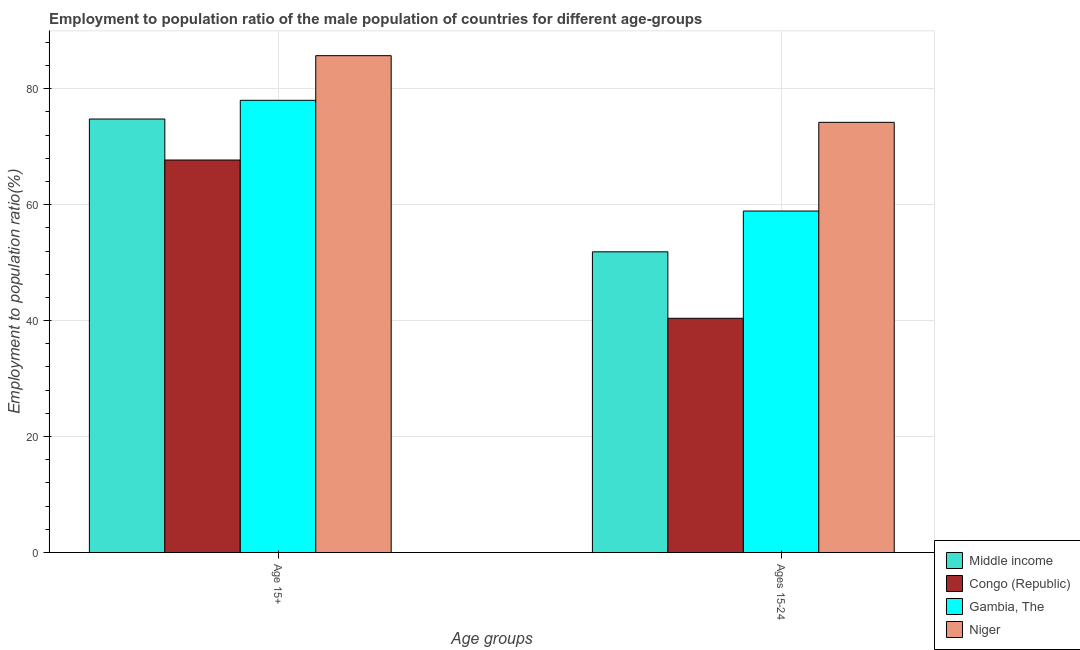How many different coloured bars are there?
Make the answer very short. 4. What is the label of the 2nd group of bars from the left?
Keep it short and to the point. Ages 15-24. What is the employment to population ratio(age 15-24) in Gambia, The?
Keep it short and to the point. 58.9. Across all countries, what is the maximum employment to population ratio(age 15-24)?
Offer a terse response. 74.2. Across all countries, what is the minimum employment to population ratio(age 15-24)?
Your answer should be compact. 40.4. In which country was the employment to population ratio(age 15+) maximum?
Make the answer very short. Niger. In which country was the employment to population ratio(age 15+) minimum?
Ensure brevity in your answer.  Congo (Republic). What is the total employment to population ratio(age 15-24) in the graph?
Provide a succinct answer. 225.37. What is the difference between the employment to population ratio(age 15-24) in Congo (Republic) and that in Niger?
Provide a short and direct response. -33.8. What is the difference between the employment to population ratio(age 15-24) in Congo (Republic) and the employment to population ratio(age 15+) in Niger?
Offer a very short reply. -45.3. What is the average employment to population ratio(age 15-24) per country?
Your answer should be very brief. 56.34. What is the difference between the employment to population ratio(age 15+) and employment to population ratio(age 15-24) in Middle income?
Make the answer very short. 22.91. In how many countries, is the employment to population ratio(age 15-24) greater than 80 %?
Give a very brief answer. 0. What is the ratio of the employment to population ratio(age 15-24) in Middle income to that in Congo (Republic)?
Provide a succinct answer. 1.28. Is the employment to population ratio(age 15+) in Congo (Republic) less than that in Gambia, The?
Your answer should be very brief. Yes. What does the 3rd bar from the left in Age 15+ represents?
Make the answer very short. Gambia, The. What does the 1st bar from the right in Age 15+ represents?
Offer a very short reply. Niger. How many countries are there in the graph?
Keep it short and to the point. 4. What is the difference between two consecutive major ticks on the Y-axis?
Give a very brief answer. 20. Are the values on the major ticks of Y-axis written in scientific E-notation?
Keep it short and to the point. No. Does the graph contain any zero values?
Keep it short and to the point. No. Does the graph contain grids?
Your answer should be compact. Yes. How many legend labels are there?
Your answer should be compact. 4. How are the legend labels stacked?
Offer a very short reply. Vertical. What is the title of the graph?
Your answer should be compact. Employment to population ratio of the male population of countries for different age-groups. What is the label or title of the X-axis?
Offer a terse response. Age groups. What is the label or title of the Y-axis?
Ensure brevity in your answer.  Employment to population ratio(%). What is the Employment to population ratio(%) of Middle income in Age 15+?
Your answer should be compact. 74.77. What is the Employment to population ratio(%) in Congo (Republic) in Age 15+?
Your response must be concise. 67.7. What is the Employment to population ratio(%) in Niger in Age 15+?
Your response must be concise. 85.7. What is the Employment to population ratio(%) of Middle income in Ages 15-24?
Your answer should be very brief. 51.87. What is the Employment to population ratio(%) in Congo (Republic) in Ages 15-24?
Your answer should be compact. 40.4. What is the Employment to population ratio(%) in Gambia, The in Ages 15-24?
Your answer should be very brief. 58.9. What is the Employment to population ratio(%) of Niger in Ages 15-24?
Provide a short and direct response. 74.2. Across all Age groups, what is the maximum Employment to population ratio(%) of Middle income?
Your response must be concise. 74.77. Across all Age groups, what is the maximum Employment to population ratio(%) of Congo (Republic)?
Offer a very short reply. 67.7. Across all Age groups, what is the maximum Employment to population ratio(%) in Gambia, The?
Your answer should be compact. 78. Across all Age groups, what is the maximum Employment to population ratio(%) of Niger?
Your answer should be very brief. 85.7. Across all Age groups, what is the minimum Employment to population ratio(%) of Middle income?
Make the answer very short. 51.87. Across all Age groups, what is the minimum Employment to population ratio(%) in Congo (Republic)?
Offer a very short reply. 40.4. Across all Age groups, what is the minimum Employment to population ratio(%) in Gambia, The?
Offer a very short reply. 58.9. Across all Age groups, what is the minimum Employment to population ratio(%) of Niger?
Keep it short and to the point. 74.2. What is the total Employment to population ratio(%) in Middle income in the graph?
Make the answer very short. 126.64. What is the total Employment to population ratio(%) in Congo (Republic) in the graph?
Ensure brevity in your answer.  108.1. What is the total Employment to population ratio(%) of Gambia, The in the graph?
Offer a very short reply. 136.9. What is the total Employment to population ratio(%) in Niger in the graph?
Offer a very short reply. 159.9. What is the difference between the Employment to population ratio(%) of Middle income in Age 15+ and that in Ages 15-24?
Keep it short and to the point. 22.91. What is the difference between the Employment to population ratio(%) in Congo (Republic) in Age 15+ and that in Ages 15-24?
Provide a short and direct response. 27.3. What is the difference between the Employment to population ratio(%) of Niger in Age 15+ and that in Ages 15-24?
Offer a very short reply. 11.5. What is the difference between the Employment to population ratio(%) of Middle income in Age 15+ and the Employment to population ratio(%) of Congo (Republic) in Ages 15-24?
Provide a succinct answer. 34.37. What is the difference between the Employment to population ratio(%) of Middle income in Age 15+ and the Employment to population ratio(%) of Gambia, The in Ages 15-24?
Make the answer very short. 15.87. What is the difference between the Employment to population ratio(%) in Congo (Republic) in Age 15+ and the Employment to population ratio(%) in Gambia, The in Ages 15-24?
Keep it short and to the point. 8.8. What is the difference between the Employment to population ratio(%) in Congo (Republic) in Age 15+ and the Employment to population ratio(%) in Niger in Ages 15-24?
Your response must be concise. -6.5. What is the difference between the Employment to population ratio(%) in Gambia, The in Age 15+ and the Employment to population ratio(%) in Niger in Ages 15-24?
Give a very brief answer. 3.8. What is the average Employment to population ratio(%) of Middle income per Age groups?
Ensure brevity in your answer.  63.32. What is the average Employment to population ratio(%) of Congo (Republic) per Age groups?
Give a very brief answer. 54.05. What is the average Employment to population ratio(%) in Gambia, The per Age groups?
Make the answer very short. 68.45. What is the average Employment to population ratio(%) of Niger per Age groups?
Make the answer very short. 79.95. What is the difference between the Employment to population ratio(%) of Middle income and Employment to population ratio(%) of Congo (Republic) in Age 15+?
Offer a very short reply. 7.07. What is the difference between the Employment to population ratio(%) in Middle income and Employment to population ratio(%) in Gambia, The in Age 15+?
Ensure brevity in your answer.  -3.23. What is the difference between the Employment to population ratio(%) in Middle income and Employment to population ratio(%) in Niger in Age 15+?
Offer a terse response. -10.93. What is the difference between the Employment to population ratio(%) of Congo (Republic) and Employment to population ratio(%) of Niger in Age 15+?
Offer a terse response. -18. What is the difference between the Employment to population ratio(%) of Gambia, The and Employment to population ratio(%) of Niger in Age 15+?
Provide a succinct answer. -7.7. What is the difference between the Employment to population ratio(%) of Middle income and Employment to population ratio(%) of Congo (Republic) in Ages 15-24?
Give a very brief answer. 11.47. What is the difference between the Employment to population ratio(%) in Middle income and Employment to population ratio(%) in Gambia, The in Ages 15-24?
Provide a succinct answer. -7.03. What is the difference between the Employment to population ratio(%) of Middle income and Employment to population ratio(%) of Niger in Ages 15-24?
Keep it short and to the point. -22.33. What is the difference between the Employment to population ratio(%) of Congo (Republic) and Employment to population ratio(%) of Gambia, The in Ages 15-24?
Ensure brevity in your answer.  -18.5. What is the difference between the Employment to population ratio(%) in Congo (Republic) and Employment to population ratio(%) in Niger in Ages 15-24?
Your answer should be very brief. -33.8. What is the difference between the Employment to population ratio(%) in Gambia, The and Employment to population ratio(%) in Niger in Ages 15-24?
Provide a succinct answer. -15.3. What is the ratio of the Employment to population ratio(%) of Middle income in Age 15+ to that in Ages 15-24?
Offer a terse response. 1.44. What is the ratio of the Employment to population ratio(%) of Congo (Republic) in Age 15+ to that in Ages 15-24?
Your response must be concise. 1.68. What is the ratio of the Employment to population ratio(%) in Gambia, The in Age 15+ to that in Ages 15-24?
Give a very brief answer. 1.32. What is the ratio of the Employment to population ratio(%) in Niger in Age 15+ to that in Ages 15-24?
Keep it short and to the point. 1.16. What is the difference between the highest and the second highest Employment to population ratio(%) in Middle income?
Give a very brief answer. 22.91. What is the difference between the highest and the second highest Employment to population ratio(%) of Congo (Republic)?
Offer a very short reply. 27.3. What is the difference between the highest and the second highest Employment to population ratio(%) of Gambia, The?
Offer a terse response. 19.1. What is the difference between the highest and the second highest Employment to population ratio(%) in Niger?
Make the answer very short. 11.5. What is the difference between the highest and the lowest Employment to population ratio(%) of Middle income?
Your answer should be compact. 22.91. What is the difference between the highest and the lowest Employment to population ratio(%) of Congo (Republic)?
Keep it short and to the point. 27.3. 